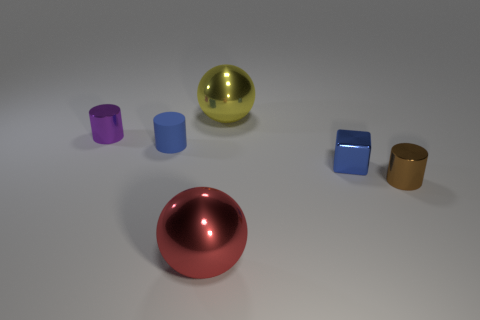Add 4 gray cylinders. How many objects exist? 10 Subtract all balls. How many objects are left? 4 Subtract 1 purple cylinders. How many objects are left? 5 Subtract all large blue rubber objects. Subtract all tiny blue metallic cubes. How many objects are left? 5 Add 4 blue metal objects. How many blue metal objects are left? 5 Add 6 brown cylinders. How many brown cylinders exist? 7 